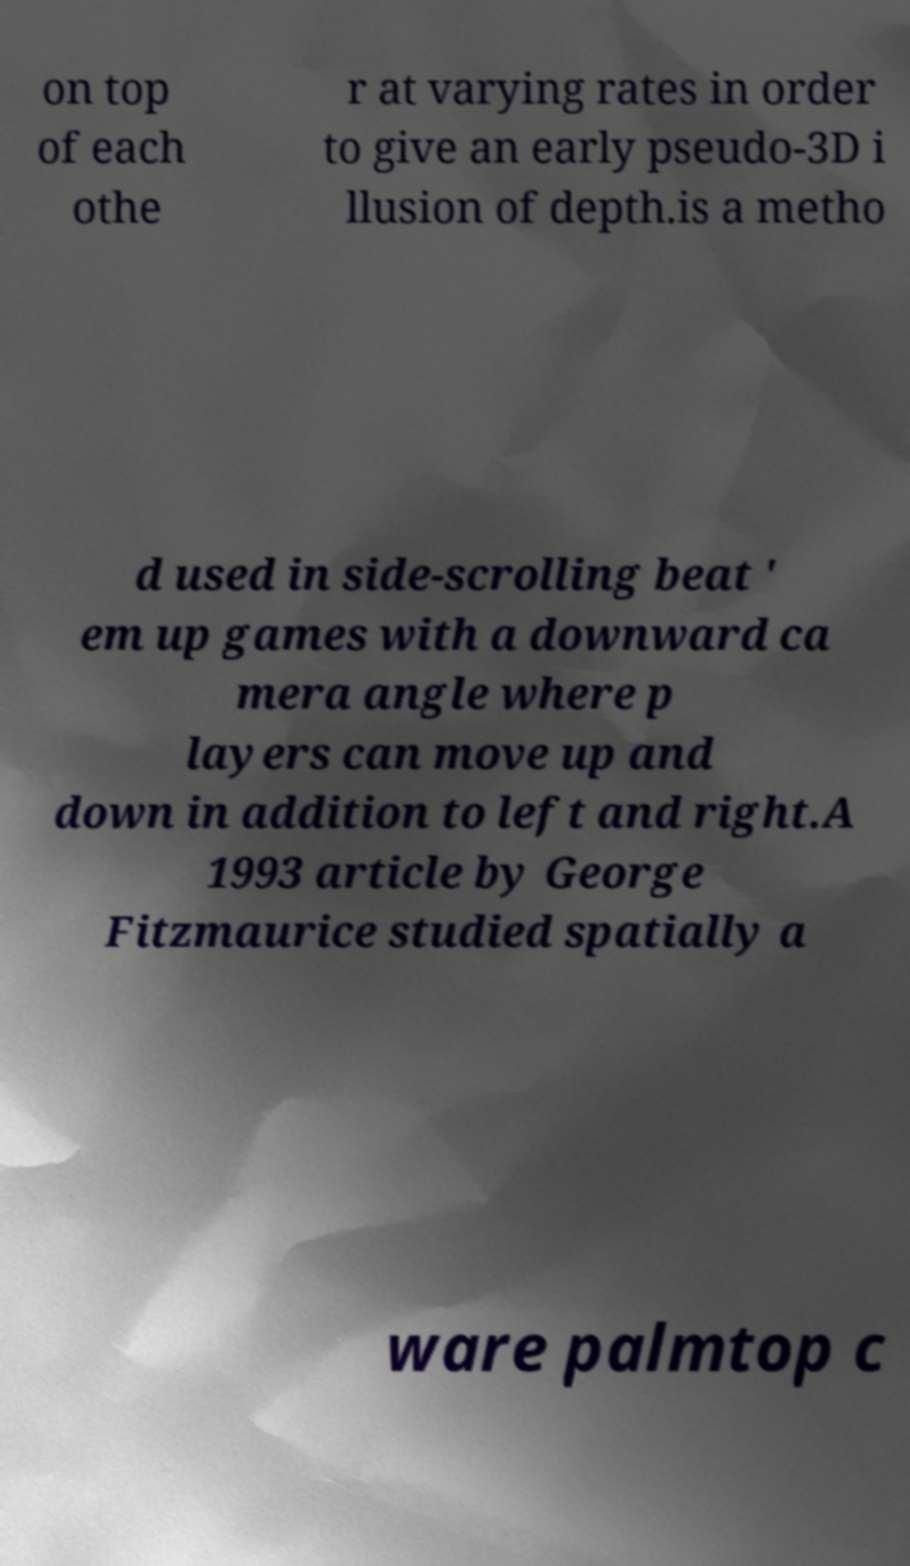Please identify and transcribe the text found in this image. on top of each othe r at varying rates in order to give an early pseudo-3D i llusion of depth.is a metho d used in side-scrolling beat ' em up games with a downward ca mera angle where p layers can move up and down in addition to left and right.A 1993 article by George Fitzmaurice studied spatially a ware palmtop c 